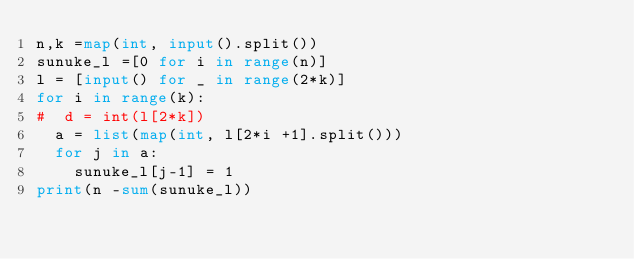<code> <loc_0><loc_0><loc_500><loc_500><_Python_>n,k =map(int, input().split())
sunuke_l =[0 for i in range(n)]
l = [input() for _ in range(2*k)]
for i in range(k):
#  d = int(l[2*k])
  a = list(map(int, l[2*i +1].split()))
  for j in a:
    sunuke_l[j-1] = 1
print(n -sum(sunuke_l))</code> 